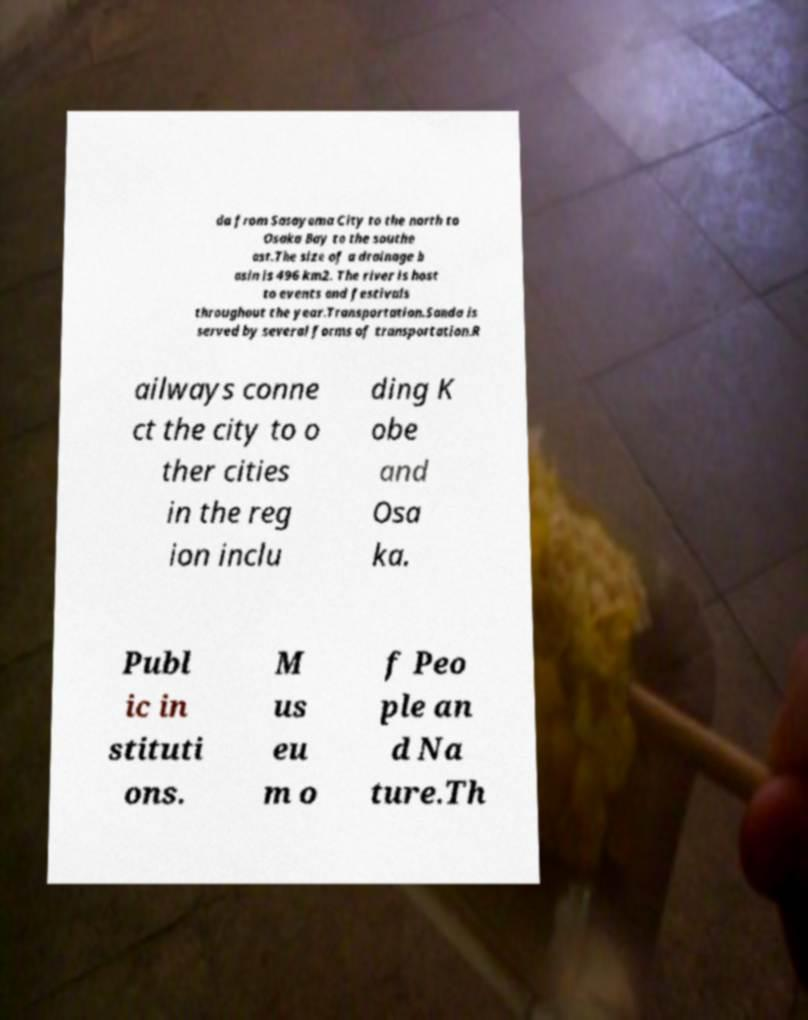Can you read and provide the text displayed in the image?This photo seems to have some interesting text. Can you extract and type it out for me? da from Sasayama City to the north to Osaka Bay to the southe ast.The size of a drainage b asin is 496 km2. The river is host to events and festivals throughout the year.Transportation.Sanda is served by several forms of transportation.R ailways conne ct the city to o ther cities in the reg ion inclu ding K obe and Osa ka. Publ ic in stituti ons. M us eu m o f Peo ple an d Na ture.Th 